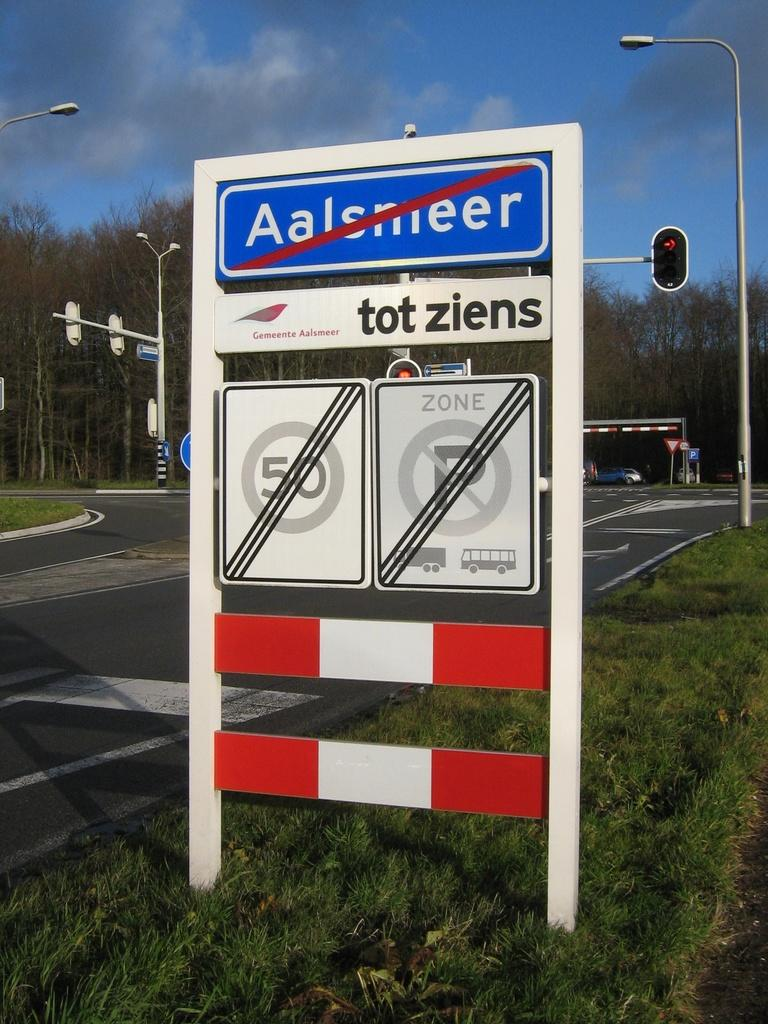Provide a one-sentence caption for the provided image. A blue sign that reads Aalsmeer has a red cross through it. 